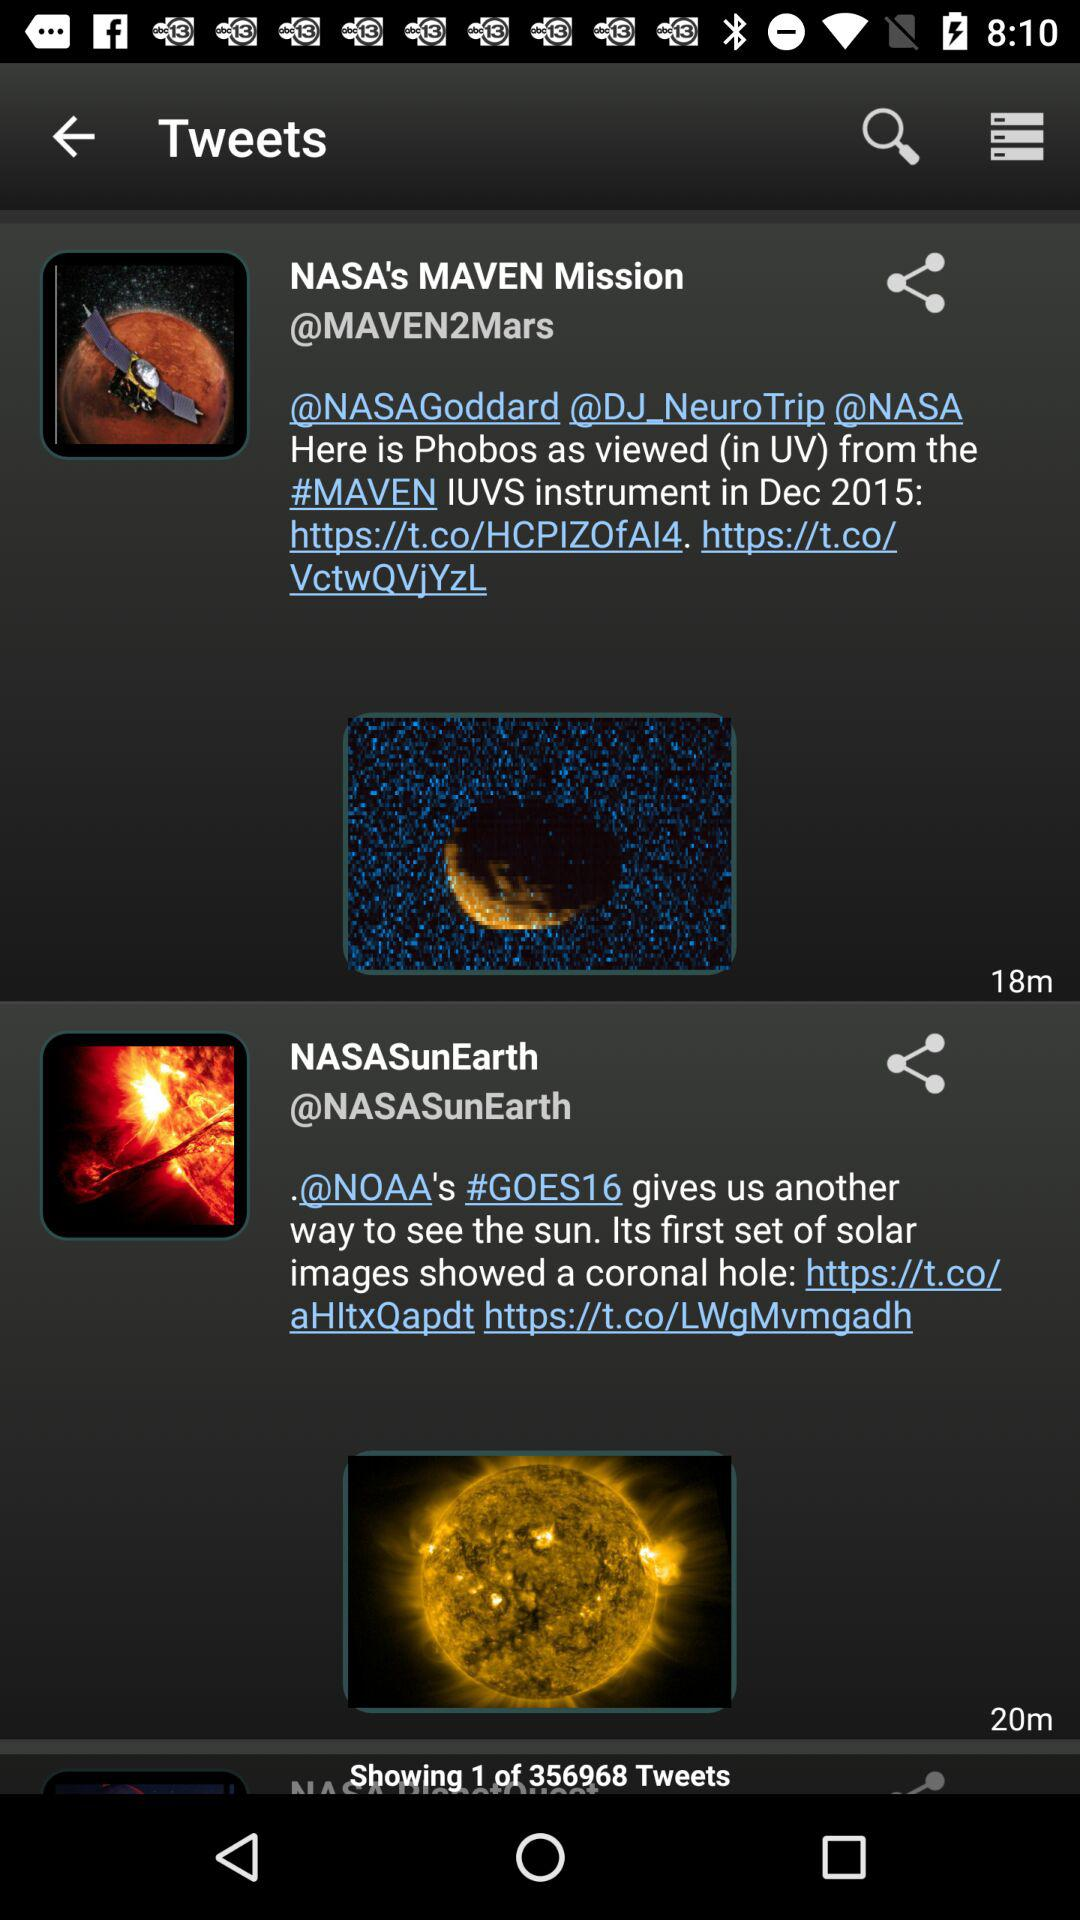What is the application name?
When the provided information is insufficient, respond with <no answer>. <no answer> 